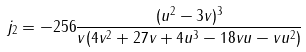Convert formula to latex. <formula><loc_0><loc_0><loc_500><loc_500>j _ { 2 } & = - 2 5 6 \frac { ( u ^ { 2 } - 3 v ) ^ { 3 } } { v ( 4 v ^ { 2 } + 2 7 v + 4 u ^ { 3 } - 1 8 v u - v u ^ { 2 } ) } \\</formula> 